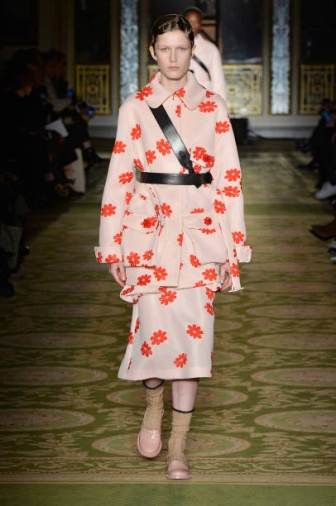Can you describe the overall feel and atmosphere of this fashion show? The fashion show exudes an air of sophistication and luxury, set within an opulent room rich with gold details and an intricately designed green runway. The atmosphere is lively yet elegant, as the audience sits captivated on either side of the runway. The model's vibrant attire adds a splash of color and creativity, enhancing the artistic and high-fashion ambiance of the event. Who are the attendees at this fashion show? The attendees of the fashion show likely include fashion industry professionals, such as designers, fashion critics, journalists, and buyers. Additionally, there might be celebrities, influencers, and other guests who are interested in fashion and the latest trends. Their presence not only adds to the glamour of the event but also signifies its significance in the fashion calendar. 